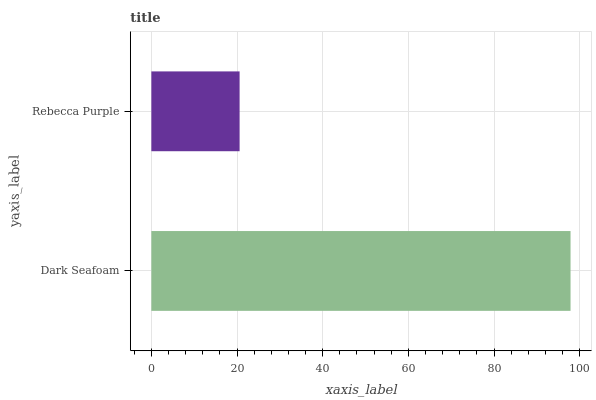Is Rebecca Purple the minimum?
Answer yes or no. Yes. Is Dark Seafoam the maximum?
Answer yes or no. Yes. Is Rebecca Purple the maximum?
Answer yes or no. No. Is Dark Seafoam greater than Rebecca Purple?
Answer yes or no. Yes. Is Rebecca Purple less than Dark Seafoam?
Answer yes or no. Yes. Is Rebecca Purple greater than Dark Seafoam?
Answer yes or no. No. Is Dark Seafoam less than Rebecca Purple?
Answer yes or no. No. Is Dark Seafoam the high median?
Answer yes or no. Yes. Is Rebecca Purple the low median?
Answer yes or no. Yes. Is Rebecca Purple the high median?
Answer yes or no. No. Is Dark Seafoam the low median?
Answer yes or no. No. 